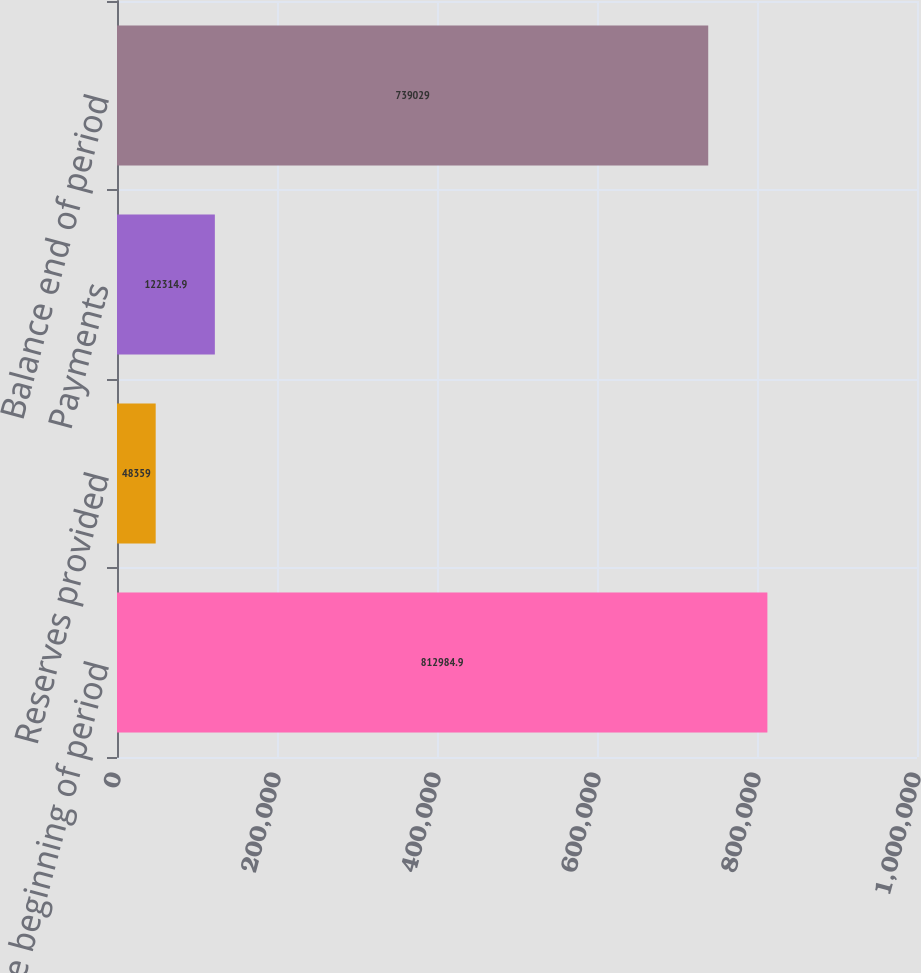Convert chart to OTSL. <chart><loc_0><loc_0><loc_500><loc_500><bar_chart><fcel>Balance beginning of period<fcel>Reserves provided<fcel>Payments<fcel>Balance end of period<nl><fcel>812985<fcel>48359<fcel>122315<fcel>739029<nl></chart> 